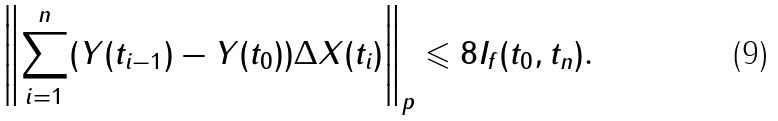Convert formula to latex. <formula><loc_0><loc_0><loc_500><loc_500>\left \| \sum _ { i = 1 } ^ { n } ( Y ( t _ { i - 1 } ) - Y ( t _ { 0 } ) ) \Delta X ( t _ { i } ) \right \| _ { p } \leqslant 8 I _ { f } ( t _ { 0 } , t _ { n } ) .</formula> 